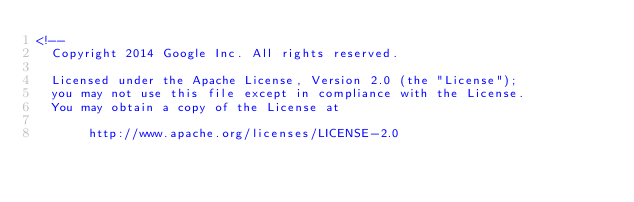<code> <loc_0><loc_0><loc_500><loc_500><_XML_><!--
  Copyright 2014 Google Inc. All rights reserved.

  Licensed under the Apache License, Version 2.0 (the "License");
  you may not use this file except in compliance with the License.
  You may obtain a copy of the License at

       http://www.apache.org/licenses/LICENSE-2.0
</code> 